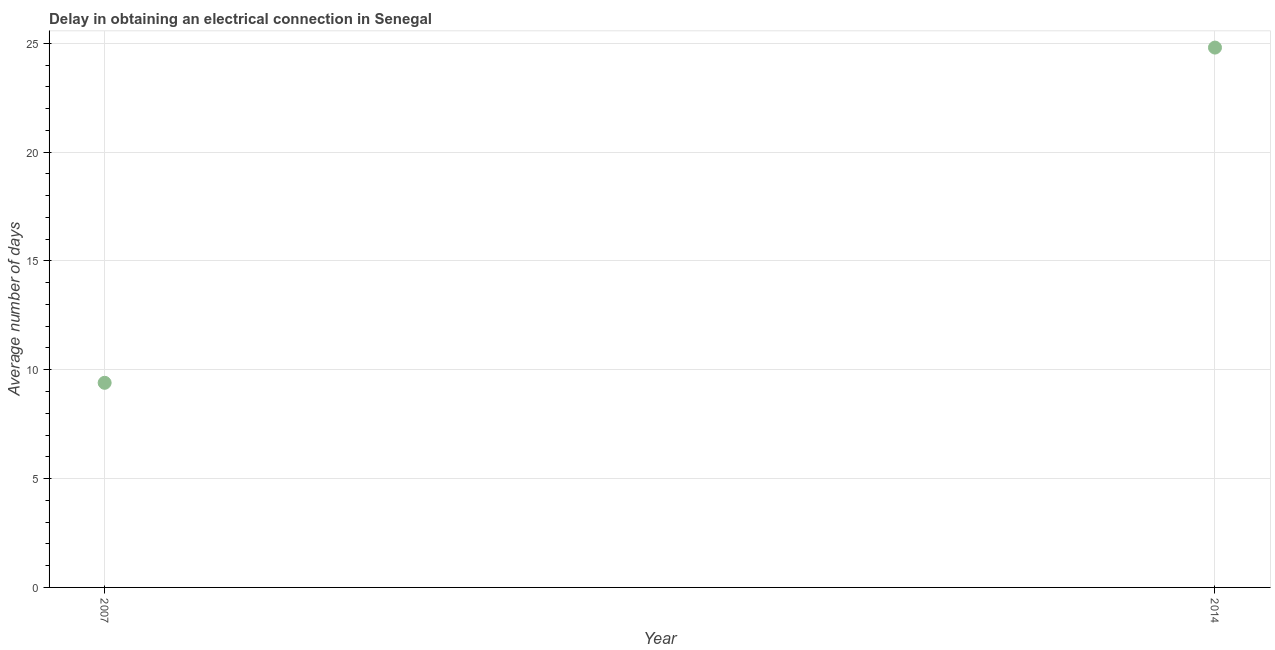Across all years, what is the maximum dalay in electrical connection?
Offer a terse response. 24.8. Across all years, what is the minimum dalay in electrical connection?
Give a very brief answer. 9.4. What is the sum of the dalay in electrical connection?
Your answer should be very brief. 34.2. What is the difference between the dalay in electrical connection in 2007 and 2014?
Your answer should be compact. -15.4. What is the average dalay in electrical connection per year?
Offer a very short reply. 17.1. In how many years, is the dalay in electrical connection greater than 17 days?
Provide a succinct answer. 1. Do a majority of the years between 2007 and 2014 (inclusive) have dalay in electrical connection greater than 3 days?
Your answer should be very brief. Yes. What is the ratio of the dalay in electrical connection in 2007 to that in 2014?
Provide a short and direct response. 0.38. Is the dalay in electrical connection in 2007 less than that in 2014?
Offer a terse response. Yes. In how many years, is the dalay in electrical connection greater than the average dalay in electrical connection taken over all years?
Offer a very short reply. 1. Does the dalay in electrical connection monotonically increase over the years?
Offer a very short reply. Yes. How many dotlines are there?
Offer a terse response. 1. How many years are there in the graph?
Give a very brief answer. 2. Does the graph contain any zero values?
Give a very brief answer. No. Does the graph contain grids?
Offer a terse response. Yes. What is the title of the graph?
Offer a very short reply. Delay in obtaining an electrical connection in Senegal. What is the label or title of the Y-axis?
Your answer should be very brief. Average number of days. What is the Average number of days in 2007?
Make the answer very short. 9.4. What is the Average number of days in 2014?
Make the answer very short. 24.8. What is the difference between the Average number of days in 2007 and 2014?
Offer a very short reply. -15.4. What is the ratio of the Average number of days in 2007 to that in 2014?
Your answer should be very brief. 0.38. 